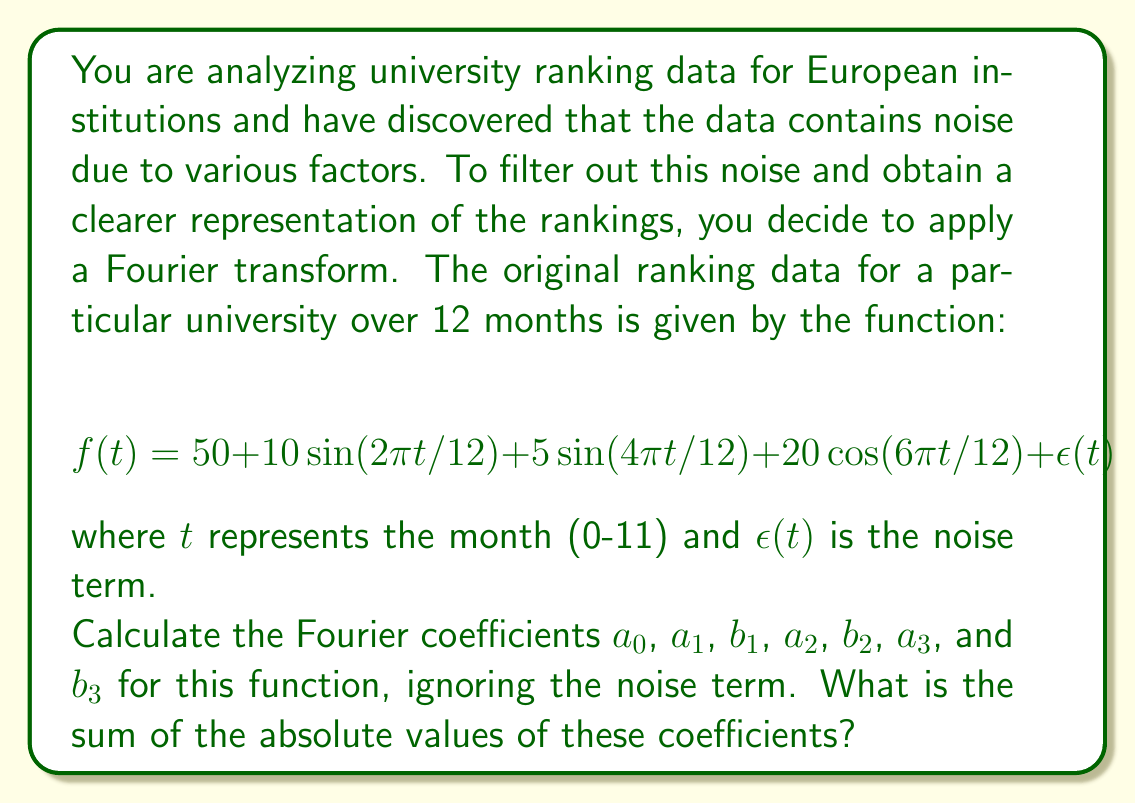What is the answer to this math problem? To solve this problem, we need to identify the Fourier coefficients from the given function and then sum their absolute values. Let's break it down step by step:

1) The general form of a Fourier series is:

   $$f(t) = a_0 + \sum_{n=1}^{\infty} (a_n \cos(n\omega t) + b_n \sin(n\omega t))$$

   where $\omega = 2\pi/T$, and $T$ is the period (in this case, 12 months).

2) Comparing our function to this general form:

   $$f(t) = 50 + 10\sin(2\pi t/12) + 5\sin(4\pi t/12) + 20\cos(6\pi t/12)$$

3) We can identify the coefficients:

   $a_0 = 50$ (the constant term)
   
   $b_1 = 10$ (coefficient of $\sin(2\pi t/12)$)
   
   $a_1 = 0$ (no $\cos(2\pi t/12)$ term)
   
   $b_2 = 5$ (coefficient of $\sin(4\pi t/12)$)
   
   $a_2 = 0$ (no $\cos(4\pi t/12)$ term)
   
   $a_3 = 20$ (coefficient of $\cos(6\pi t/12)$)
   
   $b_3 = 0$ (no $\sin(6\pi t/12)$ term)

4) Now, we need to sum the absolute values of these coefficients:

   $|a_0| + |a_1| + |b_1| + |a_2| + |b_2| + |a_3| + |b_3|$

   $= |50| + |0| + |10| + |0| + |5| + |20| + |0|$

   $= 50 + 0 + 10 + 0 + 5 + 20 + 0 = 85$

Therefore, the sum of the absolute values of the Fourier coefficients is 85.
Answer: 85 